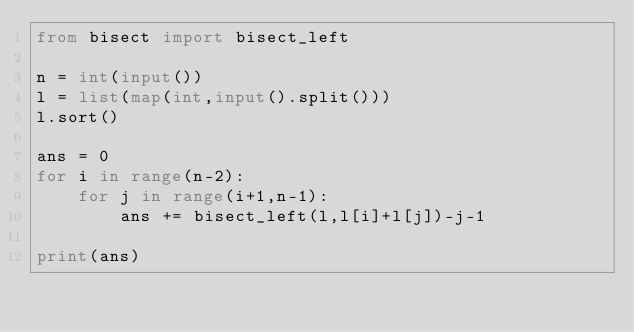Convert code to text. <code><loc_0><loc_0><loc_500><loc_500><_Python_>from bisect import bisect_left

n = int(input())
l = list(map(int,input().split()))
l.sort()

ans = 0
for i in range(n-2):
    for j in range(i+1,n-1):
        ans += bisect_left(l,l[i]+l[j])-j-1

print(ans)</code> 